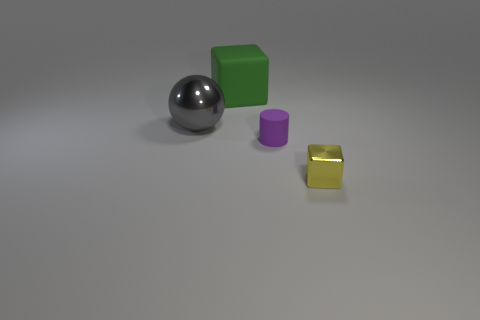Add 4 big gray balls. How many objects exist? 8 Subtract all yellow blocks. How many blocks are left? 1 Subtract 1 blocks. How many blocks are left? 1 Add 3 green matte objects. How many green matte objects exist? 4 Subtract 0 cyan cylinders. How many objects are left? 4 Subtract all cylinders. How many objects are left? 3 Subtract all green spheres. Subtract all brown cylinders. How many spheres are left? 1 Subtract all gray spheres. How many gray cylinders are left? 0 Subtract all large green spheres. Subtract all green matte cubes. How many objects are left? 3 Add 3 green objects. How many green objects are left? 4 